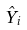<formula> <loc_0><loc_0><loc_500><loc_500>\hat { Y } _ { i }</formula> 